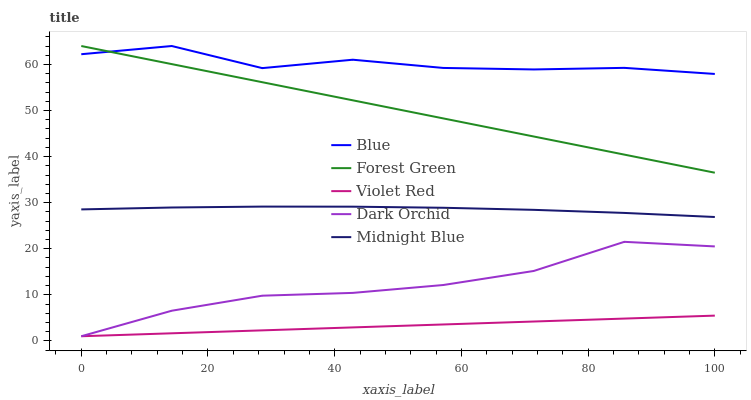Does Violet Red have the minimum area under the curve?
Answer yes or no. Yes. Does Blue have the maximum area under the curve?
Answer yes or no. Yes. Does Forest Green have the minimum area under the curve?
Answer yes or no. No. Does Forest Green have the maximum area under the curve?
Answer yes or no. No. Is Violet Red the smoothest?
Answer yes or no. Yes. Is Blue the roughest?
Answer yes or no. Yes. Is Forest Green the smoothest?
Answer yes or no. No. Is Forest Green the roughest?
Answer yes or no. No. Does Forest Green have the lowest value?
Answer yes or no. No. Does Violet Red have the highest value?
Answer yes or no. No. Is Dark Orchid less than Midnight Blue?
Answer yes or no. Yes. Is Forest Green greater than Dark Orchid?
Answer yes or no. Yes. Does Dark Orchid intersect Midnight Blue?
Answer yes or no. No. 